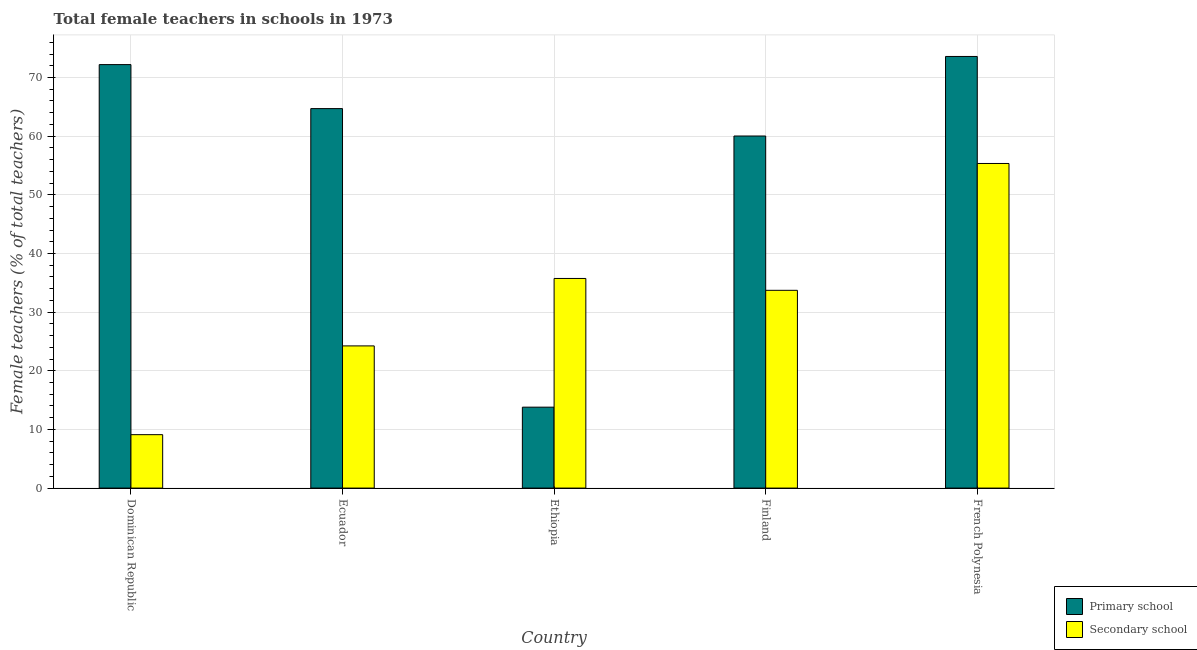How many different coloured bars are there?
Provide a short and direct response. 2. Are the number of bars per tick equal to the number of legend labels?
Provide a short and direct response. Yes. What is the label of the 4th group of bars from the left?
Keep it short and to the point. Finland. In how many cases, is the number of bars for a given country not equal to the number of legend labels?
Your answer should be very brief. 0. What is the percentage of female teachers in secondary schools in Ethiopia?
Provide a short and direct response. 35.74. Across all countries, what is the maximum percentage of female teachers in secondary schools?
Your answer should be very brief. 55.34. Across all countries, what is the minimum percentage of female teachers in primary schools?
Keep it short and to the point. 13.8. In which country was the percentage of female teachers in secondary schools maximum?
Provide a short and direct response. French Polynesia. In which country was the percentage of female teachers in primary schools minimum?
Your response must be concise. Ethiopia. What is the total percentage of female teachers in primary schools in the graph?
Provide a succinct answer. 284.31. What is the difference between the percentage of female teachers in secondary schools in Dominican Republic and that in French Polynesia?
Provide a short and direct response. -46.24. What is the difference between the percentage of female teachers in primary schools in French Polynesia and the percentage of female teachers in secondary schools in Ecuador?
Give a very brief answer. 49.35. What is the average percentage of female teachers in secondary schools per country?
Your answer should be compact. 31.63. What is the difference between the percentage of female teachers in primary schools and percentage of female teachers in secondary schools in Finland?
Provide a short and direct response. 26.31. What is the ratio of the percentage of female teachers in primary schools in Ethiopia to that in Finland?
Your answer should be compact. 0.23. Is the difference between the percentage of female teachers in primary schools in Ethiopia and French Polynesia greater than the difference between the percentage of female teachers in secondary schools in Ethiopia and French Polynesia?
Keep it short and to the point. No. What is the difference between the highest and the second highest percentage of female teachers in secondary schools?
Provide a succinct answer. 19.6. What is the difference between the highest and the lowest percentage of female teachers in secondary schools?
Make the answer very short. 46.24. In how many countries, is the percentage of female teachers in secondary schools greater than the average percentage of female teachers in secondary schools taken over all countries?
Ensure brevity in your answer.  3. Is the sum of the percentage of female teachers in secondary schools in Dominican Republic and French Polynesia greater than the maximum percentage of female teachers in primary schools across all countries?
Provide a succinct answer. No. What does the 2nd bar from the left in French Polynesia represents?
Provide a short and direct response. Secondary school. What does the 1st bar from the right in Ethiopia represents?
Ensure brevity in your answer.  Secondary school. How many bars are there?
Offer a terse response. 10. Are all the bars in the graph horizontal?
Offer a very short reply. No. How many countries are there in the graph?
Provide a short and direct response. 5. Does the graph contain any zero values?
Give a very brief answer. No. Does the graph contain grids?
Make the answer very short. Yes. How many legend labels are there?
Offer a terse response. 2. What is the title of the graph?
Make the answer very short. Total female teachers in schools in 1973. Does "Fixed telephone" appear as one of the legend labels in the graph?
Offer a very short reply. No. What is the label or title of the Y-axis?
Provide a short and direct response. Female teachers (% of total teachers). What is the Female teachers (% of total teachers) in Primary school in Dominican Republic?
Your answer should be very brief. 72.2. What is the Female teachers (% of total teachers) of Secondary school in Dominican Republic?
Ensure brevity in your answer.  9.11. What is the Female teachers (% of total teachers) of Primary school in Ecuador?
Offer a terse response. 64.7. What is the Female teachers (% of total teachers) of Secondary school in Ecuador?
Make the answer very short. 24.24. What is the Female teachers (% of total teachers) of Primary school in Ethiopia?
Ensure brevity in your answer.  13.8. What is the Female teachers (% of total teachers) in Secondary school in Ethiopia?
Provide a succinct answer. 35.74. What is the Female teachers (% of total teachers) in Primary school in Finland?
Keep it short and to the point. 60.03. What is the Female teachers (% of total teachers) in Secondary school in Finland?
Ensure brevity in your answer.  33.72. What is the Female teachers (% of total teachers) in Primary school in French Polynesia?
Your answer should be compact. 73.59. What is the Female teachers (% of total teachers) in Secondary school in French Polynesia?
Your response must be concise. 55.34. Across all countries, what is the maximum Female teachers (% of total teachers) of Primary school?
Your answer should be very brief. 73.59. Across all countries, what is the maximum Female teachers (% of total teachers) of Secondary school?
Your answer should be very brief. 55.34. Across all countries, what is the minimum Female teachers (% of total teachers) in Primary school?
Provide a succinct answer. 13.8. Across all countries, what is the minimum Female teachers (% of total teachers) of Secondary school?
Your answer should be very brief. 9.11. What is the total Female teachers (% of total teachers) in Primary school in the graph?
Ensure brevity in your answer.  284.31. What is the total Female teachers (% of total teachers) in Secondary school in the graph?
Your answer should be compact. 158.15. What is the difference between the Female teachers (% of total teachers) of Primary school in Dominican Republic and that in Ecuador?
Your answer should be very brief. 7.5. What is the difference between the Female teachers (% of total teachers) of Secondary school in Dominican Republic and that in Ecuador?
Your response must be concise. -15.13. What is the difference between the Female teachers (% of total teachers) of Primary school in Dominican Republic and that in Ethiopia?
Ensure brevity in your answer.  58.4. What is the difference between the Female teachers (% of total teachers) in Secondary school in Dominican Republic and that in Ethiopia?
Ensure brevity in your answer.  -26.63. What is the difference between the Female teachers (% of total teachers) in Primary school in Dominican Republic and that in Finland?
Provide a succinct answer. 12.17. What is the difference between the Female teachers (% of total teachers) in Secondary school in Dominican Republic and that in Finland?
Give a very brief answer. -24.61. What is the difference between the Female teachers (% of total teachers) of Primary school in Dominican Republic and that in French Polynesia?
Your answer should be compact. -1.39. What is the difference between the Female teachers (% of total teachers) in Secondary school in Dominican Republic and that in French Polynesia?
Provide a short and direct response. -46.24. What is the difference between the Female teachers (% of total teachers) in Primary school in Ecuador and that in Ethiopia?
Your answer should be compact. 50.9. What is the difference between the Female teachers (% of total teachers) in Secondary school in Ecuador and that in Ethiopia?
Your answer should be compact. -11.5. What is the difference between the Female teachers (% of total teachers) in Primary school in Ecuador and that in Finland?
Offer a very short reply. 4.67. What is the difference between the Female teachers (% of total teachers) in Secondary school in Ecuador and that in Finland?
Give a very brief answer. -9.48. What is the difference between the Female teachers (% of total teachers) of Primary school in Ecuador and that in French Polynesia?
Provide a short and direct response. -8.89. What is the difference between the Female teachers (% of total teachers) of Secondary school in Ecuador and that in French Polynesia?
Your answer should be compact. -31.1. What is the difference between the Female teachers (% of total teachers) in Primary school in Ethiopia and that in Finland?
Ensure brevity in your answer.  -46.23. What is the difference between the Female teachers (% of total teachers) in Secondary school in Ethiopia and that in Finland?
Make the answer very short. 2.02. What is the difference between the Female teachers (% of total teachers) of Primary school in Ethiopia and that in French Polynesia?
Your answer should be compact. -59.79. What is the difference between the Female teachers (% of total teachers) in Secondary school in Ethiopia and that in French Polynesia?
Provide a succinct answer. -19.6. What is the difference between the Female teachers (% of total teachers) in Primary school in Finland and that in French Polynesia?
Ensure brevity in your answer.  -13.56. What is the difference between the Female teachers (% of total teachers) in Secondary school in Finland and that in French Polynesia?
Give a very brief answer. -21.63. What is the difference between the Female teachers (% of total teachers) of Primary school in Dominican Republic and the Female teachers (% of total teachers) of Secondary school in Ecuador?
Offer a very short reply. 47.96. What is the difference between the Female teachers (% of total teachers) of Primary school in Dominican Republic and the Female teachers (% of total teachers) of Secondary school in Ethiopia?
Offer a terse response. 36.46. What is the difference between the Female teachers (% of total teachers) of Primary school in Dominican Republic and the Female teachers (% of total teachers) of Secondary school in Finland?
Make the answer very short. 38.48. What is the difference between the Female teachers (% of total teachers) of Primary school in Dominican Republic and the Female teachers (% of total teachers) of Secondary school in French Polynesia?
Provide a succinct answer. 16.86. What is the difference between the Female teachers (% of total teachers) of Primary school in Ecuador and the Female teachers (% of total teachers) of Secondary school in Ethiopia?
Your response must be concise. 28.96. What is the difference between the Female teachers (% of total teachers) of Primary school in Ecuador and the Female teachers (% of total teachers) of Secondary school in Finland?
Provide a short and direct response. 30.98. What is the difference between the Female teachers (% of total teachers) in Primary school in Ecuador and the Female teachers (% of total teachers) in Secondary school in French Polynesia?
Offer a very short reply. 9.36. What is the difference between the Female teachers (% of total teachers) of Primary school in Ethiopia and the Female teachers (% of total teachers) of Secondary school in Finland?
Keep it short and to the point. -19.92. What is the difference between the Female teachers (% of total teachers) in Primary school in Ethiopia and the Female teachers (% of total teachers) in Secondary school in French Polynesia?
Keep it short and to the point. -41.55. What is the difference between the Female teachers (% of total teachers) of Primary school in Finland and the Female teachers (% of total teachers) of Secondary school in French Polynesia?
Offer a terse response. 4.68. What is the average Female teachers (% of total teachers) of Primary school per country?
Your answer should be compact. 56.86. What is the average Female teachers (% of total teachers) in Secondary school per country?
Your response must be concise. 31.63. What is the difference between the Female teachers (% of total teachers) in Primary school and Female teachers (% of total teachers) in Secondary school in Dominican Republic?
Make the answer very short. 63.09. What is the difference between the Female teachers (% of total teachers) in Primary school and Female teachers (% of total teachers) in Secondary school in Ecuador?
Your answer should be very brief. 40.46. What is the difference between the Female teachers (% of total teachers) in Primary school and Female teachers (% of total teachers) in Secondary school in Ethiopia?
Offer a very short reply. -21.94. What is the difference between the Female teachers (% of total teachers) in Primary school and Female teachers (% of total teachers) in Secondary school in Finland?
Make the answer very short. 26.31. What is the difference between the Female teachers (% of total teachers) of Primary school and Female teachers (% of total teachers) of Secondary school in French Polynesia?
Offer a terse response. 18.25. What is the ratio of the Female teachers (% of total teachers) of Primary school in Dominican Republic to that in Ecuador?
Your answer should be very brief. 1.12. What is the ratio of the Female teachers (% of total teachers) in Secondary school in Dominican Republic to that in Ecuador?
Keep it short and to the point. 0.38. What is the ratio of the Female teachers (% of total teachers) of Primary school in Dominican Republic to that in Ethiopia?
Give a very brief answer. 5.23. What is the ratio of the Female teachers (% of total teachers) of Secondary school in Dominican Republic to that in Ethiopia?
Your answer should be compact. 0.25. What is the ratio of the Female teachers (% of total teachers) in Primary school in Dominican Republic to that in Finland?
Offer a very short reply. 1.2. What is the ratio of the Female teachers (% of total teachers) in Secondary school in Dominican Republic to that in Finland?
Provide a succinct answer. 0.27. What is the ratio of the Female teachers (% of total teachers) in Primary school in Dominican Republic to that in French Polynesia?
Ensure brevity in your answer.  0.98. What is the ratio of the Female teachers (% of total teachers) of Secondary school in Dominican Republic to that in French Polynesia?
Keep it short and to the point. 0.16. What is the ratio of the Female teachers (% of total teachers) of Primary school in Ecuador to that in Ethiopia?
Your response must be concise. 4.69. What is the ratio of the Female teachers (% of total teachers) of Secondary school in Ecuador to that in Ethiopia?
Offer a very short reply. 0.68. What is the ratio of the Female teachers (% of total teachers) in Primary school in Ecuador to that in Finland?
Give a very brief answer. 1.08. What is the ratio of the Female teachers (% of total teachers) in Secondary school in Ecuador to that in Finland?
Your answer should be very brief. 0.72. What is the ratio of the Female teachers (% of total teachers) in Primary school in Ecuador to that in French Polynesia?
Offer a very short reply. 0.88. What is the ratio of the Female teachers (% of total teachers) in Secondary school in Ecuador to that in French Polynesia?
Keep it short and to the point. 0.44. What is the ratio of the Female teachers (% of total teachers) of Primary school in Ethiopia to that in Finland?
Provide a succinct answer. 0.23. What is the ratio of the Female teachers (% of total teachers) of Secondary school in Ethiopia to that in Finland?
Your answer should be compact. 1.06. What is the ratio of the Female teachers (% of total teachers) of Primary school in Ethiopia to that in French Polynesia?
Your response must be concise. 0.19. What is the ratio of the Female teachers (% of total teachers) in Secondary school in Ethiopia to that in French Polynesia?
Offer a terse response. 0.65. What is the ratio of the Female teachers (% of total teachers) in Primary school in Finland to that in French Polynesia?
Give a very brief answer. 0.82. What is the ratio of the Female teachers (% of total teachers) in Secondary school in Finland to that in French Polynesia?
Offer a very short reply. 0.61. What is the difference between the highest and the second highest Female teachers (% of total teachers) in Primary school?
Give a very brief answer. 1.39. What is the difference between the highest and the second highest Female teachers (% of total teachers) in Secondary school?
Ensure brevity in your answer.  19.6. What is the difference between the highest and the lowest Female teachers (% of total teachers) of Primary school?
Keep it short and to the point. 59.79. What is the difference between the highest and the lowest Female teachers (% of total teachers) of Secondary school?
Make the answer very short. 46.24. 